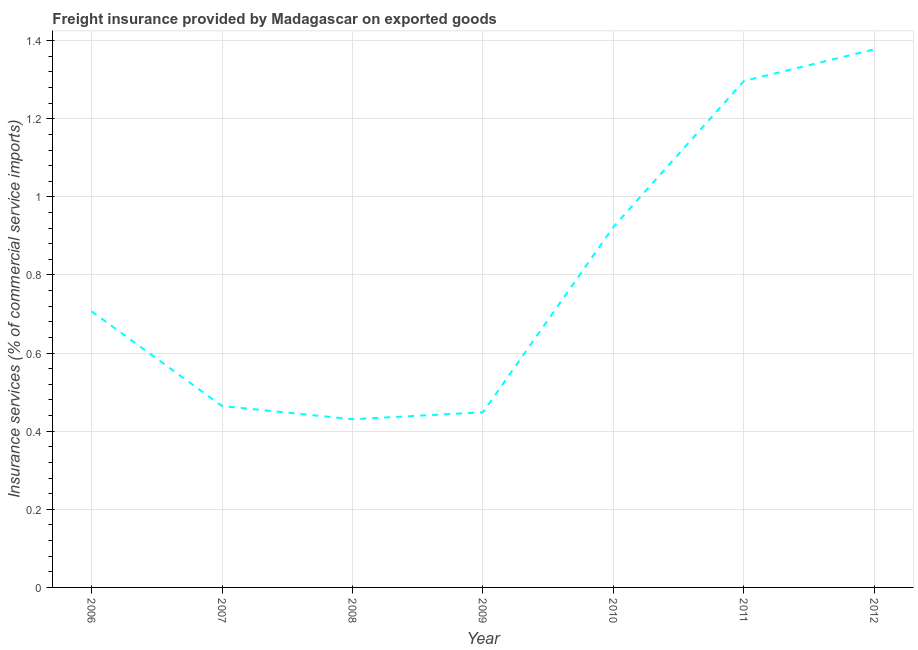What is the freight insurance in 2007?
Provide a succinct answer. 0.46. Across all years, what is the maximum freight insurance?
Give a very brief answer. 1.38. Across all years, what is the minimum freight insurance?
Keep it short and to the point. 0.43. In which year was the freight insurance maximum?
Keep it short and to the point. 2012. In which year was the freight insurance minimum?
Provide a succinct answer. 2008. What is the sum of the freight insurance?
Your answer should be very brief. 5.65. What is the difference between the freight insurance in 2007 and 2010?
Your answer should be very brief. -0.46. What is the average freight insurance per year?
Ensure brevity in your answer.  0.81. What is the median freight insurance?
Your answer should be compact. 0.71. In how many years, is the freight insurance greater than 1.2400000000000002 %?
Keep it short and to the point. 2. What is the ratio of the freight insurance in 2008 to that in 2012?
Your answer should be compact. 0.31. Is the freight insurance in 2006 less than that in 2007?
Keep it short and to the point. No. What is the difference between the highest and the second highest freight insurance?
Provide a short and direct response. 0.08. What is the difference between the highest and the lowest freight insurance?
Keep it short and to the point. 0.95. In how many years, is the freight insurance greater than the average freight insurance taken over all years?
Your response must be concise. 3. How many lines are there?
Provide a succinct answer. 1. How many years are there in the graph?
Ensure brevity in your answer.  7. Are the values on the major ticks of Y-axis written in scientific E-notation?
Offer a very short reply. No. What is the title of the graph?
Your response must be concise. Freight insurance provided by Madagascar on exported goods . What is the label or title of the X-axis?
Make the answer very short. Year. What is the label or title of the Y-axis?
Give a very brief answer. Insurance services (% of commercial service imports). What is the Insurance services (% of commercial service imports) in 2006?
Ensure brevity in your answer.  0.71. What is the Insurance services (% of commercial service imports) in 2007?
Make the answer very short. 0.46. What is the Insurance services (% of commercial service imports) of 2008?
Ensure brevity in your answer.  0.43. What is the Insurance services (% of commercial service imports) of 2009?
Provide a succinct answer. 0.45. What is the Insurance services (% of commercial service imports) of 2010?
Offer a terse response. 0.92. What is the Insurance services (% of commercial service imports) in 2011?
Your response must be concise. 1.3. What is the Insurance services (% of commercial service imports) in 2012?
Your answer should be compact. 1.38. What is the difference between the Insurance services (% of commercial service imports) in 2006 and 2007?
Offer a terse response. 0.24. What is the difference between the Insurance services (% of commercial service imports) in 2006 and 2008?
Make the answer very short. 0.28. What is the difference between the Insurance services (% of commercial service imports) in 2006 and 2009?
Your answer should be very brief. 0.26. What is the difference between the Insurance services (% of commercial service imports) in 2006 and 2010?
Offer a terse response. -0.22. What is the difference between the Insurance services (% of commercial service imports) in 2006 and 2011?
Offer a very short reply. -0.59. What is the difference between the Insurance services (% of commercial service imports) in 2006 and 2012?
Ensure brevity in your answer.  -0.67. What is the difference between the Insurance services (% of commercial service imports) in 2007 and 2008?
Provide a short and direct response. 0.03. What is the difference between the Insurance services (% of commercial service imports) in 2007 and 2009?
Provide a succinct answer. 0.02. What is the difference between the Insurance services (% of commercial service imports) in 2007 and 2010?
Provide a short and direct response. -0.46. What is the difference between the Insurance services (% of commercial service imports) in 2007 and 2011?
Your answer should be compact. -0.83. What is the difference between the Insurance services (% of commercial service imports) in 2007 and 2012?
Give a very brief answer. -0.91. What is the difference between the Insurance services (% of commercial service imports) in 2008 and 2009?
Offer a very short reply. -0.02. What is the difference between the Insurance services (% of commercial service imports) in 2008 and 2010?
Give a very brief answer. -0.49. What is the difference between the Insurance services (% of commercial service imports) in 2008 and 2011?
Provide a short and direct response. -0.87. What is the difference between the Insurance services (% of commercial service imports) in 2008 and 2012?
Make the answer very short. -0.95. What is the difference between the Insurance services (% of commercial service imports) in 2009 and 2010?
Keep it short and to the point. -0.47. What is the difference between the Insurance services (% of commercial service imports) in 2009 and 2011?
Your answer should be very brief. -0.85. What is the difference between the Insurance services (% of commercial service imports) in 2009 and 2012?
Your answer should be compact. -0.93. What is the difference between the Insurance services (% of commercial service imports) in 2010 and 2011?
Your answer should be very brief. -0.37. What is the difference between the Insurance services (% of commercial service imports) in 2010 and 2012?
Provide a succinct answer. -0.45. What is the difference between the Insurance services (% of commercial service imports) in 2011 and 2012?
Ensure brevity in your answer.  -0.08. What is the ratio of the Insurance services (% of commercial service imports) in 2006 to that in 2007?
Your response must be concise. 1.52. What is the ratio of the Insurance services (% of commercial service imports) in 2006 to that in 2008?
Offer a very short reply. 1.64. What is the ratio of the Insurance services (% of commercial service imports) in 2006 to that in 2009?
Your answer should be very brief. 1.58. What is the ratio of the Insurance services (% of commercial service imports) in 2006 to that in 2010?
Make the answer very short. 0.77. What is the ratio of the Insurance services (% of commercial service imports) in 2006 to that in 2011?
Ensure brevity in your answer.  0.55. What is the ratio of the Insurance services (% of commercial service imports) in 2006 to that in 2012?
Provide a succinct answer. 0.51. What is the ratio of the Insurance services (% of commercial service imports) in 2007 to that in 2008?
Make the answer very short. 1.08. What is the ratio of the Insurance services (% of commercial service imports) in 2007 to that in 2009?
Give a very brief answer. 1.04. What is the ratio of the Insurance services (% of commercial service imports) in 2007 to that in 2010?
Offer a terse response. 0.5. What is the ratio of the Insurance services (% of commercial service imports) in 2007 to that in 2011?
Your answer should be compact. 0.36. What is the ratio of the Insurance services (% of commercial service imports) in 2007 to that in 2012?
Offer a very short reply. 0.34. What is the ratio of the Insurance services (% of commercial service imports) in 2008 to that in 2009?
Your answer should be compact. 0.96. What is the ratio of the Insurance services (% of commercial service imports) in 2008 to that in 2010?
Provide a short and direct response. 0.47. What is the ratio of the Insurance services (% of commercial service imports) in 2008 to that in 2011?
Keep it short and to the point. 0.33. What is the ratio of the Insurance services (% of commercial service imports) in 2008 to that in 2012?
Your answer should be very brief. 0.31. What is the ratio of the Insurance services (% of commercial service imports) in 2009 to that in 2010?
Give a very brief answer. 0.49. What is the ratio of the Insurance services (% of commercial service imports) in 2009 to that in 2011?
Provide a succinct answer. 0.35. What is the ratio of the Insurance services (% of commercial service imports) in 2009 to that in 2012?
Your answer should be very brief. 0.33. What is the ratio of the Insurance services (% of commercial service imports) in 2010 to that in 2011?
Your response must be concise. 0.71. What is the ratio of the Insurance services (% of commercial service imports) in 2010 to that in 2012?
Your answer should be compact. 0.67. What is the ratio of the Insurance services (% of commercial service imports) in 2011 to that in 2012?
Ensure brevity in your answer.  0.94. 